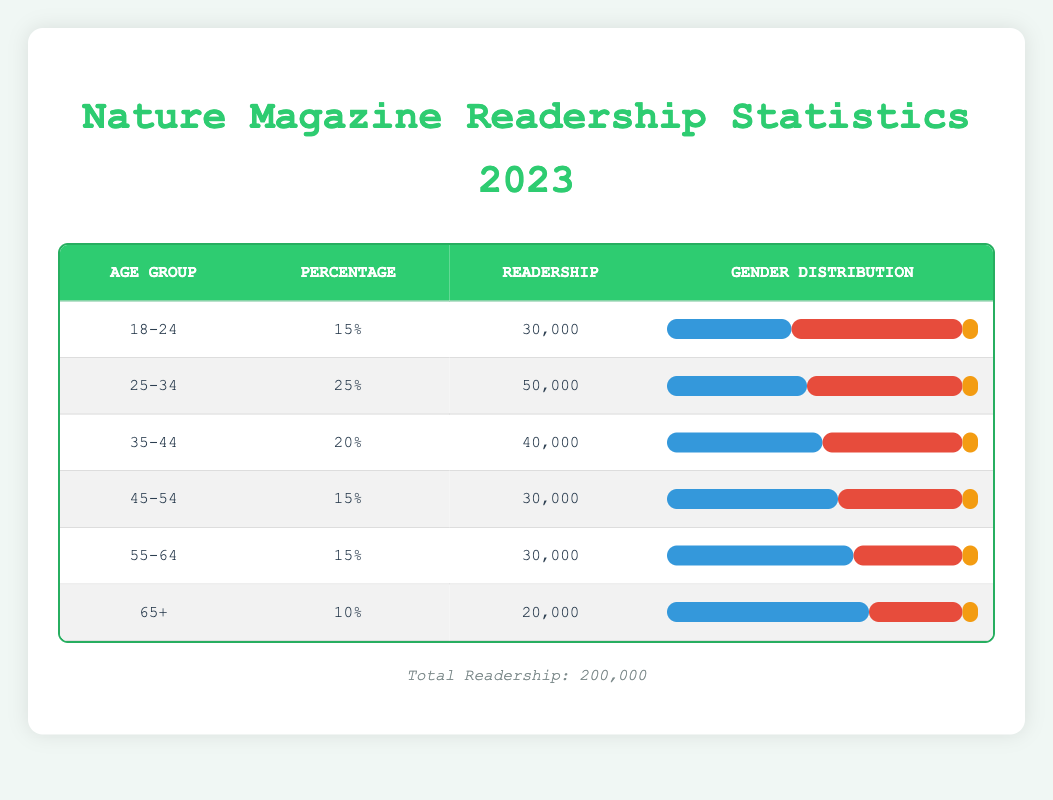What is the percentage of readership for the age group 25-34? The table shows that for the age group 25-34, the percentage listed is 25%.
Answer: 25% Which age group has the highest readership? The age group with the highest readership can be found by comparing the "Readership" values across all age groups. The age group 25-34 has a readership of 50,000, which is the highest.
Answer: 25-34 What is the total readership of the 65+ age group? The "Readership" figure for the 65+ age group can be directly taken from the table which states it is 20,000.
Answer: 20,000 In the 45-54 age group, what is the male percentage distribution? The male percentage for the 45-54 age group is listed as 55%. This can be found in the "Gender Distribution" column for that specific age group.
Answer: 55% What is the average readership across all age groups? The total readership is 200,000, and there are six age groups. Therefore, to find the average, divide 200,000 by 6, which equals approximately 33,333.33.
Answer: 33,333.33 Does the female readership percentage in the 18-24 age group exceed that of the 35-44 age group? For the 18-24 age group, the female percentage is 55%, while for the 35-44 age group, it is 45%. Since 55% is greater than 45%, the statement is true.
Answer: Yes What is the difference in readership between the 35-44 and 55-64 age groups? The readership for the 35-44 age group is 40,000 and for the 55-64 age group is 30,000. To find the difference, subtract 30,000 from 40,000, which results in 10,000.
Answer: 10,000 Which age group has the lowest percentage of male readership? By examining the "Gender Distribution" percentages, the 18-24 age group has a male percentage of 40%, which is the lowest among all age groups.
Answer: 18-24 Is the percentage of readership in the 65+ age group below 15%? The 65+ age group shows a percentage of 10%, which is indeed below 15%. Thus, the statement is true.
Answer: Yes 